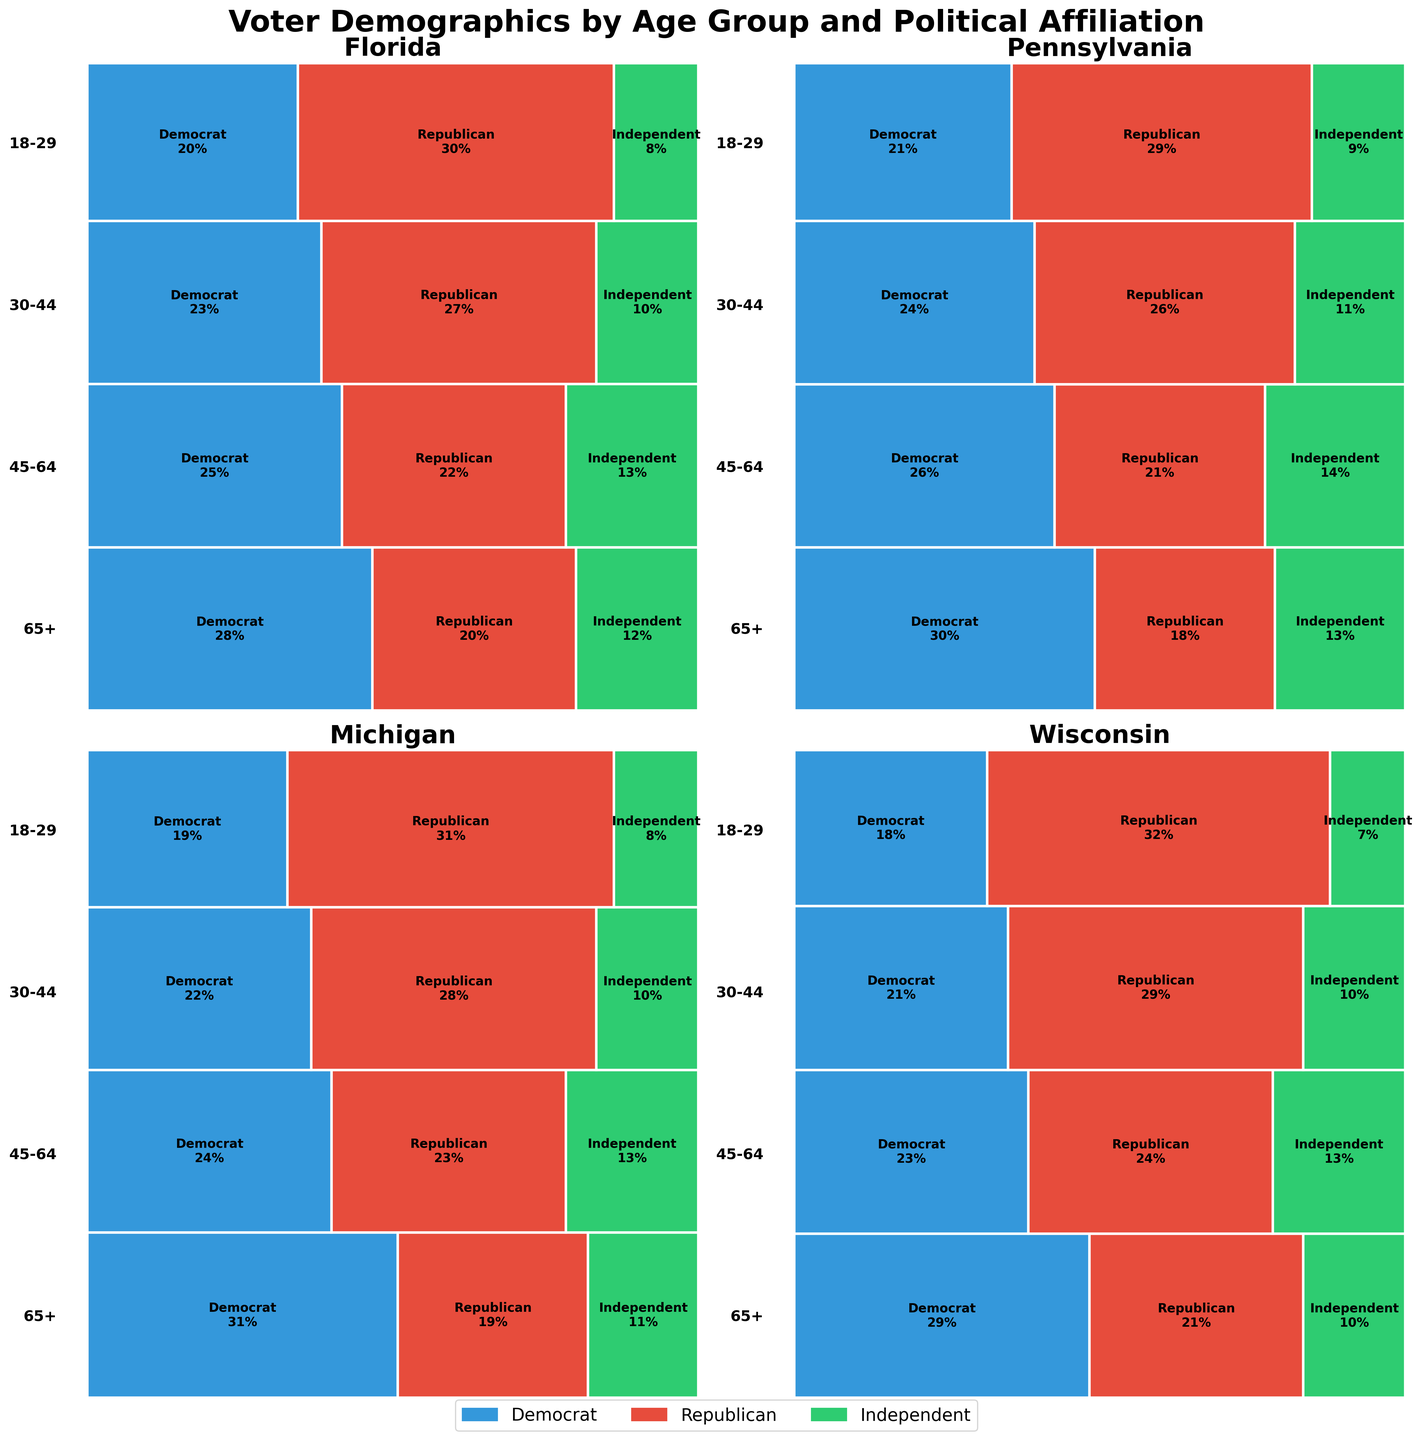What's the proportion of 18-29 year-old Democrats in Florida? Look at the "Florida" tile for the 18-29 age group and note the width of the blue section. It represents Democrats. The text label shows the percentage directly as 28.
Answer: 28% Which age group has the highest Republican representation in Pennsylvania? Look at the "Pennsylvania" mosaic. Compare the widths of the red (Republican) sections across all age groups. The age group 65+ has the widest red section labeled as 29%.
Answer: 65+ How does the number of 45-64 year-old Independents compare between Michigan and Wisconsin? Look at the 45-64 age group tiles in Michigan and Wisconsin. The width of the green sections represents Independents, both are labeled 10%, so they are equal.
Answer: Equal What is the total number of Democrats in the 30-44 age group across all states? Sum the Democratic percentages in the 30-44 age group across Florida (25), Pennsylvania (26), Michigan (24), and Wisconsin (23). Total = 25 + 26 + 24 + 23 = 98.
Answer: 98 In Wisconsin, which political affiliation has the smallest proportional representation in the 65+ age group? Look at the 65+ age group in Wisconsin. The green section (Independent) has the smallest width and is labeled as 7%.
Answer: Independents What is the percentage difference between Republicans and Democrats in the 18-29 age group in Pennsylvania? Find the Republican and Democrat percentages in the 18-29 age group in Pennsylvania: Republicans (18%), Democrats (30%). The difference is 30% - 18% = 12%.
Answer: 12% Which state has the most balanced representation among Democrats, Republicans, and Independents in the 30-44 age group? Compare the widths of the blue, red, and green sections in the 30-44 age group across all states. Michigan shows the most balanced proportions: Democrats (24%), Republicans (23%), and Independents (13%).
Answer: Michigan How does the proportion of 65+ Republicans in Michigan compare to that in Wisconsin? Locate the 65+ age group tiles in both Michigan and Wisconsin, and compare the widths of the red sections. Michigan has a Republican proportion of 31%, while Wisconsin has 32%.
Answer: Lower What percentage of voters in the 45-64 age group in Florida are non-Republican? Calculate the percentage of non-Republicans by summing Democrats (23%) and Independents (10%) in the 45-64 age group in Florida. The result is 23% + 10% = 33%.
Answer: 33% Which age group has the smallest total proportion of Independents across all states? Compare the green sections (Independents) across all age groups in each state. The 65+ age group shows the smallest total proportions summed as follows: Florida (8%), Pennsylvania (9%), Michigan (8%), Wisconsin (7%). Sum = 8 + 9 + 8 + 7 = 32.
Answer: 65+ 